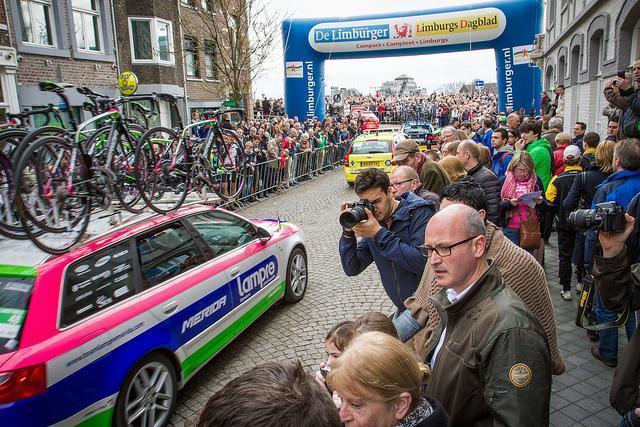How many bicycles are there?
Give a very brief answer. 3. How many cars are there?
Give a very brief answer. 2. How many people are there?
Give a very brief answer. 5. How many slices of pizza are left of the fork?
Give a very brief answer. 0. 